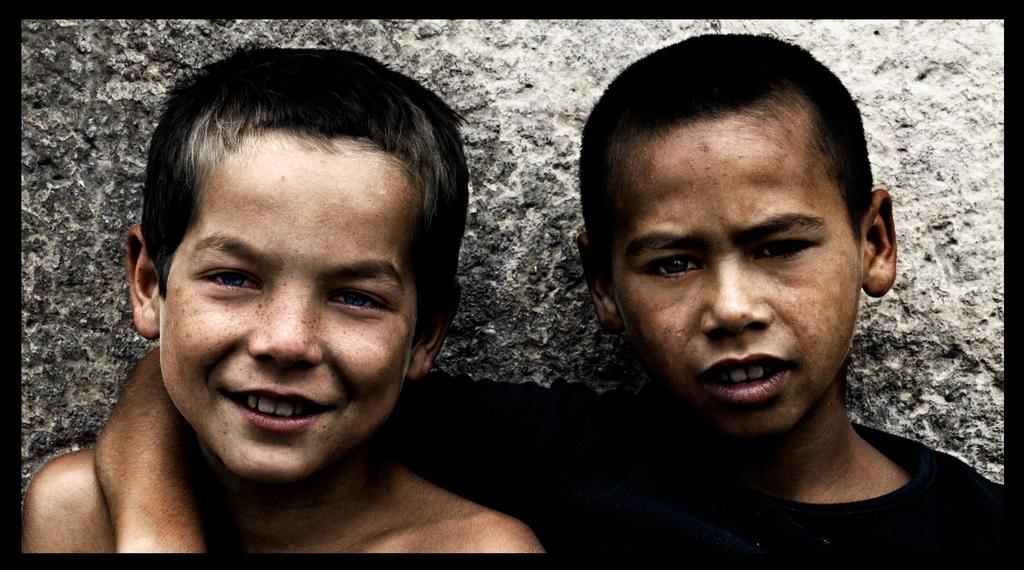How many boys are in the image? There are two boys in the image. What is the boy wearing on the left side of the image wearing? One of the boys is wearing a black dress. What expression does the boy with the black dress have? The boy with the black dress has a smile on his face. What type of veil can be seen on the boy's head in the image? There is no veil present on the boy's head in the image. Can you tell me how the boy is interacting with himself in the image? The image does not show the boy interacting with himself; he is simply standing with a smile on his face. 